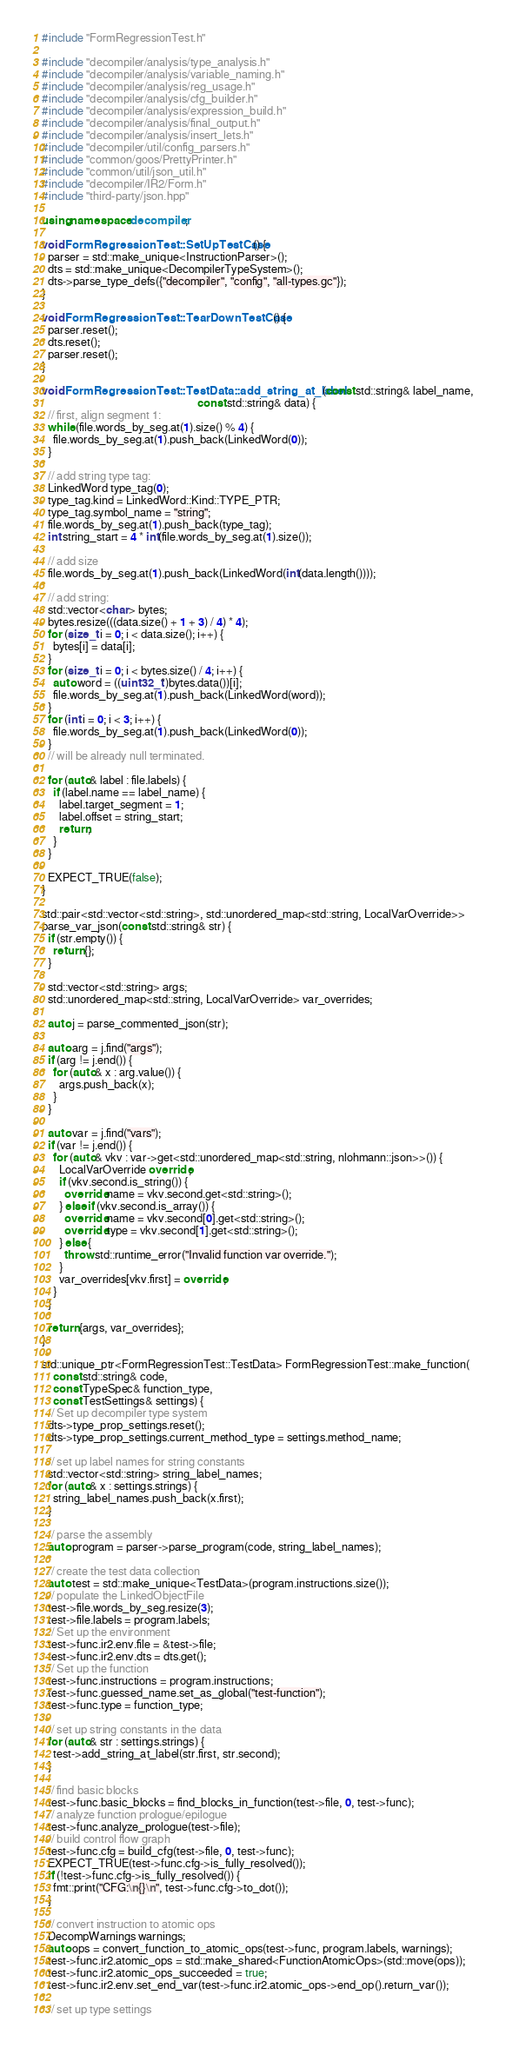Convert code to text. <code><loc_0><loc_0><loc_500><loc_500><_C++_>#include "FormRegressionTest.h"

#include "decompiler/analysis/type_analysis.h"
#include "decompiler/analysis/variable_naming.h"
#include "decompiler/analysis/reg_usage.h"
#include "decompiler/analysis/cfg_builder.h"
#include "decompiler/analysis/expression_build.h"
#include "decompiler/analysis/final_output.h"
#include "decompiler/analysis/insert_lets.h"
#include "decompiler/util/config_parsers.h"
#include "common/goos/PrettyPrinter.h"
#include "common/util/json_util.h"
#include "decompiler/IR2/Form.h"
#include "third-party/json.hpp"

using namespace decompiler;

void FormRegressionTest::SetUpTestCase() {
  parser = std::make_unique<InstructionParser>();
  dts = std::make_unique<DecompilerTypeSystem>();
  dts->parse_type_defs({"decompiler", "config", "all-types.gc"});
}

void FormRegressionTest::TearDownTestCase() {
  parser.reset();
  dts.reset();
  parser.reset();
}

void FormRegressionTest::TestData::add_string_at_label(const std::string& label_name,
                                                       const std::string& data) {
  // first, align segment 1:
  while (file.words_by_seg.at(1).size() % 4) {
    file.words_by_seg.at(1).push_back(LinkedWord(0));
  }

  // add string type tag:
  LinkedWord type_tag(0);
  type_tag.kind = LinkedWord::Kind::TYPE_PTR;
  type_tag.symbol_name = "string";
  file.words_by_seg.at(1).push_back(type_tag);
  int string_start = 4 * int(file.words_by_seg.at(1).size());

  // add size
  file.words_by_seg.at(1).push_back(LinkedWord(int(data.length())));

  // add string:
  std::vector<char> bytes;
  bytes.resize(((data.size() + 1 + 3) / 4) * 4);
  for (size_t i = 0; i < data.size(); i++) {
    bytes[i] = data[i];
  }
  for (size_t i = 0; i < bytes.size() / 4; i++) {
    auto word = ((uint32_t*)bytes.data())[i];
    file.words_by_seg.at(1).push_back(LinkedWord(word));
  }
  for (int i = 0; i < 3; i++) {
    file.words_by_seg.at(1).push_back(LinkedWord(0));
  }
  // will be already null terminated.

  for (auto& label : file.labels) {
    if (label.name == label_name) {
      label.target_segment = 1;
      label.offset = string_start;
      return;
    }
  }

  EXPECT_TRUE(false);
}

std::pair<std::vector<std::string>, std::unordered_map<std::string, LocalVarOverride>>
parse_var_json(const std::string& str) {
  if (str.empty()) {
    return {};
  }

  std::vector<std::string> args;
  std::unordered_map<std::string, LocalVarOverride> var_overrides;

  auto j = parse_commented_json(str);

  auto arg = j.find("args");
  if (arg != j.end()) {
    for (auto& x : arg.value()) {
      args.push_back(x);
    }
  }

  auto var = j.find("vars");
  if (var != j.end()) {
    for (auto& vkv : var->get<std::unordered_map<std::string, nlohmann::json>>()) {
      LocalVarOverride override;
      if (vkv.second.is_string()) {
        override.name = vkv.second.get<std::string>();
      } else if (vkv.second.is_array()) {
        override.name = vkv.second[0].get<std::string>();
        override.type = vkv.second[1].get<std::string>();
      } else {
        throw std::runtime_error("Invalid function var override.");
      }
      var_overrides[vkv.first] = override;
    }
  }

  return {args, var_overrides};
}

std::unique_ptr<FormRegressionTest::TestData> FormRegressionTest::make_function(
    const std::string& code,
    const TypeSpec& function_type,
    const TestSettings& settings) {
  // Set up decompiler type system
  dts->type_prop_settings.reset();
  dts->type_prop_settings.current_method_type = settings.method_name;

  // set up label names for string constants
  std::vector<std::string> string_label_names;
  for (auto& x : settings.strings) {
    string_label_names.push_back(x.first);
  }

  // parse the assembly
  auto program = parser->parse_program(code, string_label_names);

  // create the test data collection
  auto test = std::make_unique<TestData>(program.instructions.size());
  // populate the LinkedObjectFile
  test->file.words_by_seg.resize(3);
  test->file.labels = program.labels;
  // Set up the environment
  test->func.ir2.env.file = &test->file;
  test->func.ir2.env.dts = dts.get();
  // Set up the function
  test->func.instructions = program.instructions;
  test->func.guessed_name.set_as_global("test-function");
  test->func.type = function_type;

  // set up string constants in the data
  for (auto& str : settings.strings) {
    test->add_string_at_label(str.first, str.second);
  }

  // find basic blocks
  test->func.basic_blocks = find_blocks_in_function(test->file, 0, test->func);
  // analyze function prologue/epilogue
  test->func.analyze_prologue(test->file);
  // build control flow graph
  test->func.cfg = build_cfg(test->file, 0, test->func);
  EXPECT_TRUE(test->func.cfg->is_fully_resolved());
  if (!test->func.cfg->is_fully_resolved()) {
    fmt::print("CFG:\n{}\n", test->func.cfg->to_dot());
  }

  // convert instruction to atomic ops
  DecompWarnings warnings;
  auto ops = convert_function_to_atomic_ops(test->func, program.labels, warnings);
  test->func.ir2.atomic_ops = std::make_shared<FunctionAtomicOps>(std::move(ops));
  test->func.ir2.atomic_ops_succeeded = true;
  test->func.ir2.env.set_end_var(test->func.ir2.atomic_ops->end_op().return_var());

  // set up type settings</code> 